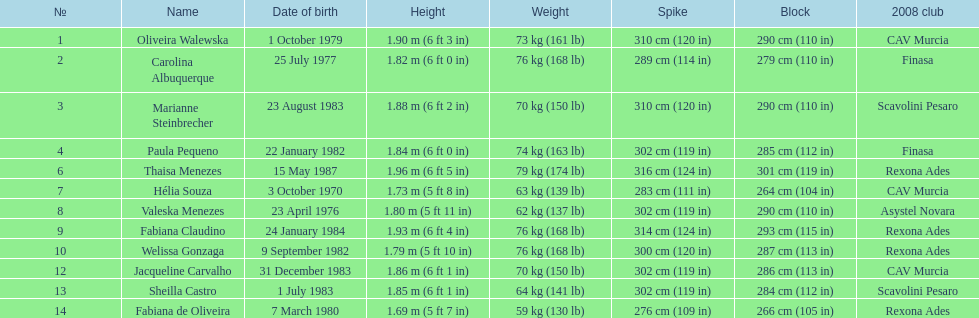Help me parse the entirety of this table. {'header': ['№', 'Name', 'Date of birth', 'Height', 'Weight', 'Spike', 'Block', '2008 club'], 'rows': [['1', 'Oliveira Walewska', '1 October 1979', '1.90\xa0m (6\xa0ft 3\xa0in)', '73\xa0kg (161\xa0lb)', '310\xa0cm (120\xa0in)', '290\xa0cm (110\xa0in)', 'CAV Murcia'], ['2', 'Carolina Albuquerque', '25 July 1977', '1.82\xa0m (6\xa0ft 0\xa0in)', '76\xa0kg (168\xa0lb)', '289\xa0cm (114\xa0in)', '279\xa0cm (110\xa0in)', 'Finasa'], ['3', 'Marianne Steinbrecher', '23 August 1983', '1.88\xa0m (6\xa0ft 2\xa0in)', '70\xa0kg (150\xa0lb)', '310\xa0cm (120\xa0in)', '290\xa0cm (110\xa0in)', 'Scavolini Pesaro'], ['4', 'Paula Pequeno', '22 January 1982', '1.84\xa0m (6\xa0ft 0\xa0in)', '74\xa0kg (163\xa0lb)', '302\xa0cm (119\xa0in)', '285\xa0cm (112\xa0in)', 'Finasa'], ['6', 'Thaisa Menezes', '15 May 1987', '1.96\xa0m (6\xa0ft 5\xa0in)', '79\xa0kg (174\xa0lb)', '316\xa0cm (124\xa0in)', '301\xa0cm (119\xa0in)', 'Rexona Ades'], ['7', 'Hélia Souza', '3 October 1970', '1.73\xa0m (5\xa0ft 8\xa0in)', '63\xa0kg (139\xa0lb)', '283\xa0cm (111\xa0in)', '264\xa0cm (104\xa0in)', 'CAV Murcia'], ['8', 'Valeska Menezes', '23 April 1976', '1.80\xa0m (5\xa0ft 11\xa0in)', '62\xa0kg (137\xa0lb)', '302\xa0cm (119\xa0in)', '290\xa0cm (110\xa0in)', 'Asystel Novara'], ['9', 'Fabiana Claudino', '24 January 1984', '1.93\xa0m (6\xa0ft 4\xa0in)', '76\xa0kg (168\xa0lb)', '314\xa0cm (124\xa0in)', '293\xa0cm (115\xa0in)', 'Rexona Ades'], ['10', 'Welissa Gonzaga', '9 September 1982', '1.79\xa0m (5\xa0ft 10\xa0in)', '76\xa0kg (168\xa0lb)', '300\xa0cm (120\xa0in)', '287\xa0cm (113\xa0in)', 'Rexona Ades'], ['12', 'Jacqueline Carvalho', '31 December 1983', '1.86\xa0m (6\xa0ft 1\xa0in)', '70\xa0kg (150\xa0lb)', '302\xa0cm (119\xa0in)', '286\xa0cm (113\xa0in)', 'CAV Murcia'], ['13', 'Sheilla Castro', '1 July 1983', '1.85\xa0m (6\xa0ft 1\xa0in)', '64\xa0kg (141\xa0lb)', '302\xa0cm (119\xa0in)', '284\xa0cm (112\xa0in)', 'Scavolini Pesaro'], ['14', 'Fabiana de Oliveira', '7 March 1980', '1.69\xa0m (5\xa0ft 7\xa0in)', '59\xa0kg (130\xa0lb)', '276\xa0cm (109\xa0in)', '266\xa0cm (105\xa0in)', 'Rexona Ades']]} Which athlete has the shortest height of just 5 feet 7 inches? Fabiana de Oliveira. 